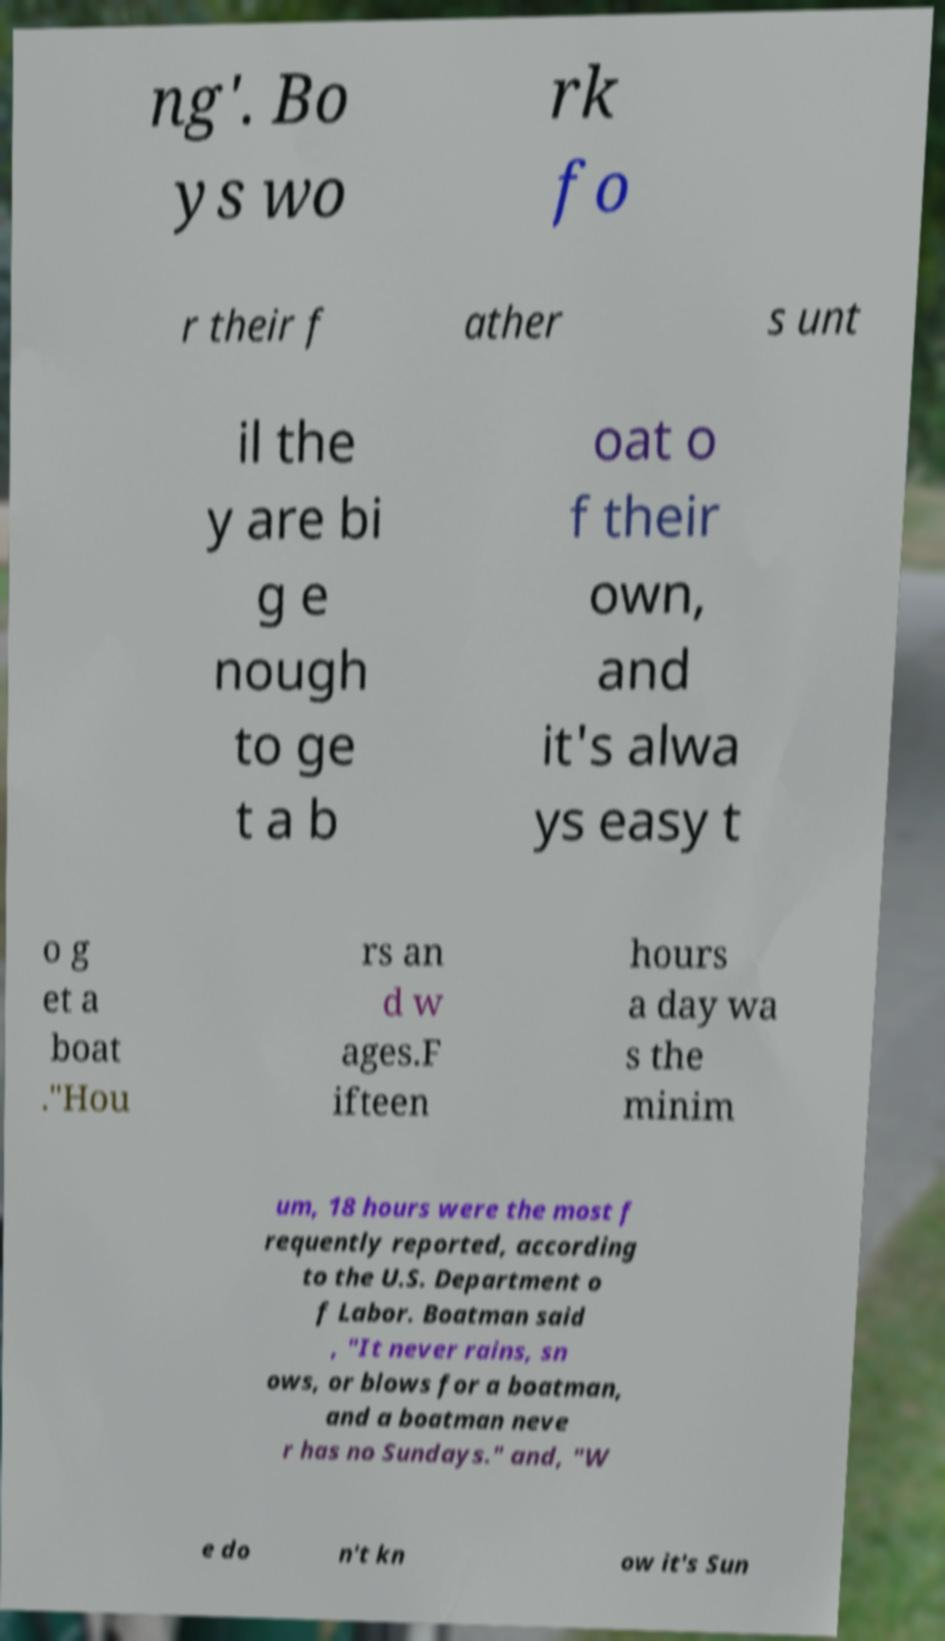Please read and relay the text visible in this image. What does it say? ng'. Bo ys wo rk fo r their f ather s unt il the y are bi g e nough to ge t a b oat o f their own, and it's alwa ys easy t o g et a boat ."Hou rs an d w ages.F ifteen hours a day wa s the minim um, 18 hours were the most f requently reported, according to the U.S. Department o f Labor. Boatman said , "It never rains, sn ows, or blows for a boatman, and a boatman neve r has no Sundays." and, "W e do n't kn ow it's Sun 